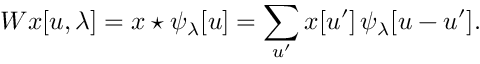Convert formula to latex. <formula><loc_0><loc_0><loc_500><loc_500>W x [ u , \lambda ] = x ^ { * } \psi _ { \lambda } [ u ] = \sum _ { u ^ { \prime } } x [ u ^ { \prime } ] \, \psi _ { \lambda } [ u - u ^ { \prime } ] .</formula> 